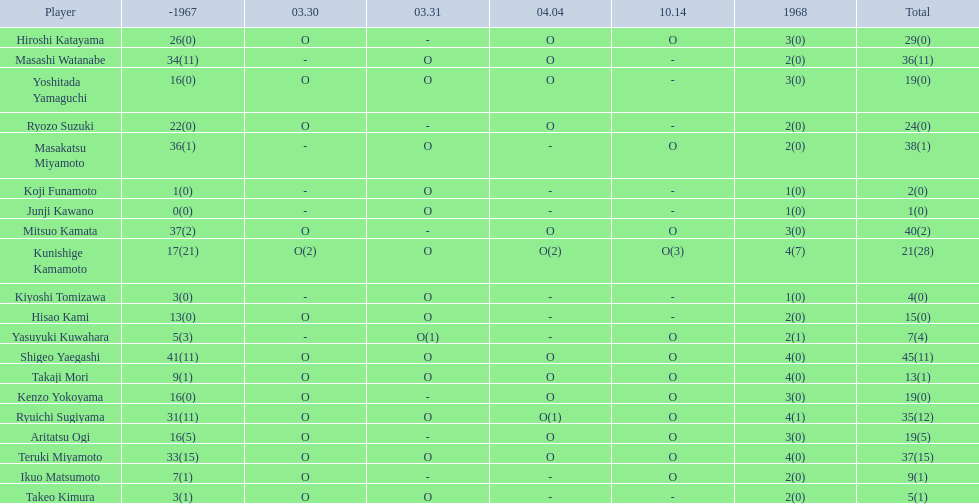Who were the players in the 1968 japanese football? Shigeo Yaegashi, Mitsuo Kamata, Masakatsu Miyamoto, Masashi Watanabe, Teruki Miyamoto, Ryuichi Sugiyama, Hiroshi Katayama, Ryozo Suzuki, Kunishige Kamamoto, Aritatsu Ogi, Yoshitada Yamaguchi, Kenzo Yokoyama, Hisao Kami, Takaji Mori, Ikuo Matsumoto, Yasuyuki Kuwahara, Takeo Kimura, Kiyoshi Tomizawa, Koji Funamoto, Junji Kawano. How many points total did takaji mori have? 13(1). How many points total did junju kawano? 1(0). Who had more points? Takaji Mori. 